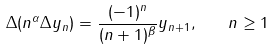<formula> <loc_0><loc_0><loc_500><loc_500>\Delta ( n ^ { \alpha } \Delta y _ { n } ) = \frac { ( - 1 ) ^ { n } } { ( n + 1 ) ^ { \beta } } y _ { n + 1 } , \quad n \geq 1</formula> 